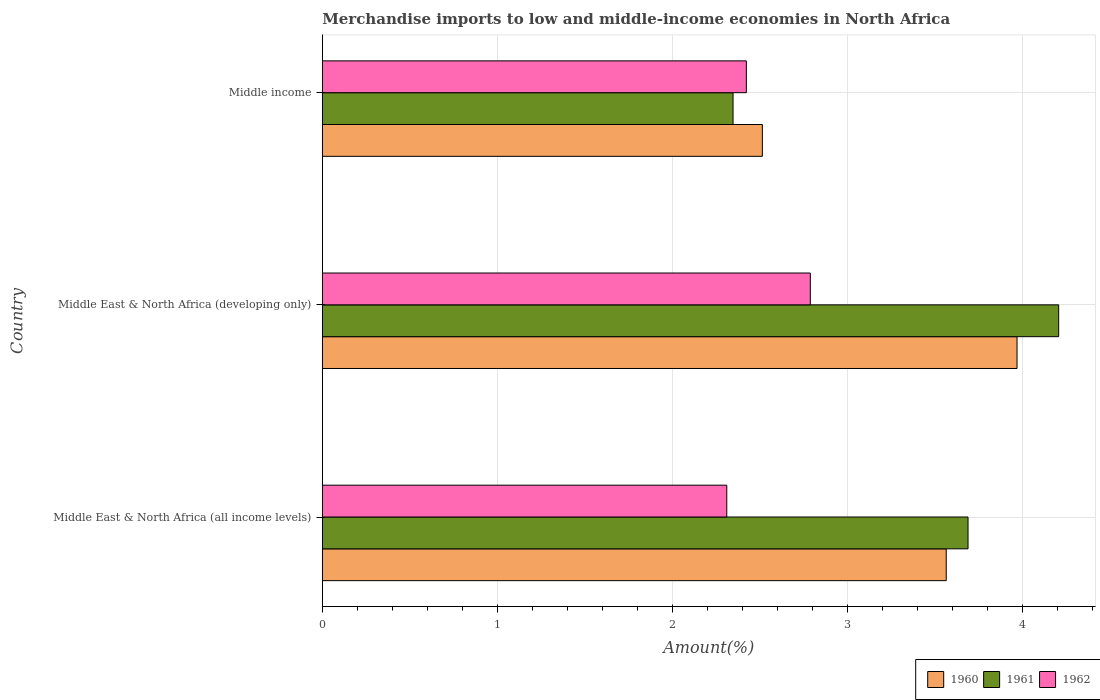How many groups of bars are there?
Provide a short and direct response. 3. Are the number of bars per tick equal to the number of legend labels?
Your answer should be compact. Yes. Are the number of bars on each tick of the Y-axis equal?
Offer a very short reply. Yes. How many bars are there on the 2nd tick from the top?
Provide a short and direct response. 3. How many bars are there on the 1st tick from the bottom?
Offer a very short reply. 3. What is the label of the 2nd group of bars from the top?
Ensure brevity in your answer.  Middle East & North Africa (developing only). In how many cases, is the number of bars for a given country not equal to the number of legend labels?
Offer a terse response. 0. What is the percentage of amount earned from merchandise imports in 1962 in Middle East & North Africa (all income levels)?
Offer a very short reply. 2.31. Across all countries, what is the maximum percentage of amount earned from merchandise imports in 1962?
Offer a terse response. 2.79. Across all countries, what is the minimum percentage of amount earned from merchandise imports in 1962?
Keep it short and to the point. 2.31. In which country was the percentage of amount earned from merchandise imports in 1961 maximum?
Make the answer very short. Middle East & North Africa (developing only). In which country was the percentage of amount earned from merchandise imports in 1960 minimum?
Offer a terse response. Middle income. What is the total percentage of amount earned from merchandise imports in 1960 in the graph?
Offer a very short reply. 10.05. What is the difference between the percentage of amount earned from merchandise imports in 1960 in Middle East & North Africa (developing only) and that in Middle income?
Provide a short and direct response. 1.46. What is the difference between the percentage of amount earned from merchandise imports in 1961 in Middle income and the percentage of amount earned from merchandise imports in 1962 in Middle East & North Africa (all income levels)?
Provide a short and direct response. 0.04. What is the average percentage of amount earned from merchandise imports in 1961 per country?
Give a very brief answer. 3.42. What is the difference between the percentage of amount earned from merchandise imports in 1960 and percentage of amount earned from merchandise imports in 1962 in Middle East & North Africa (all income levels)?
Keep it short and to the point. 1.25. What is the ratio of the percentage of amount earned from merchandise imports in 1962 in Middle East & North Africa (all income levels) to that in Middle East & North Africa (developing only)?
Ensure brevity in your answer.  0.83. Is the percentage of amount earned from merchandise imports in 1960 in Middle East & North Africa (all income levels) less than that in Middle East & North Africa (developing only)?
Make the answer very short. Yes. What is the difference between the highest and the second highest percentage of amount earned from merchandise imports in 1960?
Your response must be concise. 0.4. What is the difference between the highest and the lowest percentage of amount earned from merchandise imports in 1960?
Ensure brevity in your answer.  1.46. In how many countries, is the percentage of amount earned from merchandise imports in 1960 greater than the average percentage of amount earned from merchandise imports in 1960 taken over all countries?
Offer a terse response. 2. Is the sum of the percentage of amount earned from merchandise imports in 1960 in Middle East & North Africa (developing only) and Middle income greater than the maximum percentage of amount earned from merchandise imports in 1961 across all countries?
Ensure brevity in your answer.  Yes. What does the 2nd bar from the top in Middle East & North Africa (developing only) represents?
Offer a very short reply. 1961. Are all the bars in the graph horizontal?
Make the answer very short. Yes. How many countries are there in the graph?
Your answer should be compact. 3. Does the graph contain any zero values?
Offer a very short reply. No. What is the title of the graph?
Your answer should be compact. Merchandise imports to low and middle-income economies in North Africa. Does "2014" appear as one of the legend labels in the graph?
Make the answer very short. No. What is the label or title of the X-axis?
Provide a short and direct response. Amount(%). What is the Amount(%) of 1960 in Middle East & North Africa (all income levels)?
Provide a succinct answer. 3.57. What is the Amount(%) of 1961 in Middle East & North Africa (all income levels)?
Provide a short and direct response. 3.69. What is the Amount(%) in 1962 in Middle East & North Africa (all income levels)?
Your response must be concise. 2.31. What is the Amount(%) in 1960 in Middle East & North Africa (developing only)?
Provide a succinct answer. 3.97. What is the Amount(%) of 1961 in Middle East & North Africa (developing only)?
Offer a very short reply. 4.21. What is the Amount(%) in 1962 in Middle East & North Africa (developing only)?
Your answer should be compact. 2.79. What is the Amount(%) in 1960 in Middle income?
Ensure brevity in your answer.  2.52. What is the Amount(%) of 1961 in Middle income?
Your answer should be compact. 2.35. What is the Amount(%) of 1962 in Middle income?
Offer a very short reply. 2.42. Across all countries, what is the maximum Amount(%) of 1960?
Ensure brevity in your answer.  3.97. Across all countries, what is the maximum Amount(%) of 1961?
Provide a succinct answer. 4.21. Across all countries, what is the maximum Amount(%) of 1962?
Offer a terse response. 2.79. Across all countries, what is the minimum Amount(%) in 1960?
Offer a very short reply. 2.52. Across all countries, what is the minimum Amount(%) of 1961?
Keep it short and to the point. 2.35. Across all countries, what is the minimum Amount(%) in 1962?
Provide a short and direct response. 2.31. What is the total Amount(%) in 1960 in the graph?
Your answer should be compact. 10.05. What is the total Amount(%) of 1961 in the graph?
Offer a terse response. 10.25. What is the total Amount(%) in 1962 in the graph?
Your answer should be compact. 7.53. What is the difference between the Amount(%) of 1960 in Middle East & North Africa (all income levels) and that in Middle East & North Africa (developing only)?
Ensure brevity in your answer.  -0.4. What is the difference between the Amount(%) in 1961 in Middle East & North Africa (all income levels) and that in Middle East & North Africa (developing only)?
Your answer should be very brief. -0.52. What is the difference between the Amount(%) of 1962 in Middle East & North Africa (all income levels) and that in Middle East & North Africa (developing only)?
Your answer should be very brief. -0.48. What is the difference between the Amount(%) of 1960 in Middle East & North Africa (all income levels) and that in Middle income?
Offer a terse response. 1.05. What is the difference between the Amount(%) of 1961 in Middle East & North Africa (all income levels) and that in Middle income?
Keep it short and to the point. 1.34. What is the difference between the Amount(%) in 1962 in Middle East & North Africa (all income levels) and that in Middle income?
Provide a succinct answer. -0.11. What is the difference between the Amount(%) of 1960 in Middle East & North Africa (developing only) and that in Middle income?
Give a very brief answer. 1.46. What is the difference between the Amount(%) of 1961 in Middle East & North Africa (developing only) and that in Middle income?
Your answer should be compact. 1.86. What is the difference between the Amount(%) of 1962 in Middle East & North Africa (developing only) and that in Middle income?
Keep it short and to the point. 0.37. What is the difference between the Amount(%) in 1960 in Middle East & North Africa (all income levels) and the Amount(%) in 1961 in Middle East & North Africa (developing only)?
Offer a terse response. -0.64. What is the difference between the Amount(%) in 1960 in Middle East & North Africa (all income levels) and the Amount(%) in 1962 in Middle East & North Africa (developing only)?
Give a very brief answer. 0.78. What is the difference between the Amount(%) of 1961 in Middle East & North Africa (all income levels) and the Amount(%) of 1962 in Middle East & North Africa (developing only)?
Make the answer very short. 0.9. What is the difference between the Amount(%) of 1960 in Middle East & North Africa (all income levels) and the Amount(%) of 1961 in Middle income?
Ensure brevity in your answer.  1.22. What is the difference between the Amount(%) of 1960 in Middle East & North Africa (all income levels) and the Amount(%) of 1962 in Middle income?
Your answer should be very brief. 1.14. What is the difference between the Amount(%) in 1961 in Middle East & North Africa (all income levels) and the Amount(%) in 1962 in Middle income?
Your answer should be compact. 1.27. What is the difference between the Amount(%) of 1960 in Middle East & North Africa (developing only) and the Amount(%) of 1961 in Middle income?
Your answer should be compact. 1.62. What is the difference between the Amount(%) in 1960 in Middle East & North Africa (developing only) and the Amount(%) in 1962 in Middle income?
Provide a succinct answer. 1.55. What is the difference between the Amount(%) of 1961 in Middle East & North Africa (developing only) and the Amount(%) of 1962 in Middle income?
Make the answer very short. 1.79. What is the average Amount(%) of 1960 per country?
Offer a terse response. 3.35. What is the average Amount(%) in 1961 per country?
Your answer should be compact. 3.42. What is the average Amount(%) of 1962 per country?
Ensure brevity in your answer.  2.51. What is the difference between the Amount(%) of 1960 and Amount(%) of 1961 in Middle East & North Africa (all income levels)?
Keep it short and to the point. -0.12. What is the difference between the Amount(%) of 1960 and Amount(%) of 1962 in Middle East & North Africa (all income levels)?
Make the answer very short. 1.25. What is the difference between the Amount(%) of 1961 and Amount(%) of 1962 in Middle East & North Africa (all income levels)?
Offer a terse response. 1.38. What is the difference between the Amount(%) of 1960 and Amount(%) of 1961 in Middle East & North Africa (developing only)?
Offer a terse response. -0.24. What is the difference between the Amount(%) of 1960 and Amount(%) of 1962 in Middle East & North Africa (developing only)?
Keep it short and to the point. 1.18. What is the difference between the Amount(%) in 1961 and Amount(%) in 1962 in Middle East & North Africa (developing only)?
Offer a terse response. 1.42. What is the difference between the Amount(%) of 1960 and Amount(%) of 1961 in Middle income?
Your answer should be compact. 0.17. What is the difference between the Amount(%) in 1960 and Amount(%) in 1962 in Middle income?
Make the answer very short. 0.09. What is the difference between the Amount(%) in 1961 and Amount(%) in 1962 in Middle income?
Provide a succinct answer. -0.08. What is the ratio of the Amount(%) of 1960 in Middle East & North Africa (all income levels) to that in Middle East & North Africa (developing only)?
Your answer should be compact. 0.9. What is the ratio of the Amount(%) in 1961 in Middle East & North Africa (all income levels) to that in Middle East & North Africa (developing only)?
Provide a short and direct response. 0.88. What is the ratio of the Amount(%) of 1962 in Middle East & North Africa (all income levels) to that in Middle East & North Africa (developing only)?
Give a very brief answer. 0.83. What is the ratio of the Amount(%) in 1960 in Middle East & North Africa (all income levels) to that in Middle income?
Make the answer very short. 1.42. What is the ratio of the Amount(%) in 1961 in Middle East & North Africa (all income levels) to that in Middle income?
Your answer should be very brief. 1.57. What is the ratio of the Amount(%) of 1962 in Middle East & North Africa (all income levels) to that in Middle income?
Offer a very short reply. 0.95. What is the ratio of the Amount(%) of 1960 in Middle East & North Africa (developing only) to that in Middle income?
Make the answer very short. 1.58. What is the ratio of the Amount(%) of 1961 in Middle East & North Africa (developing only) to that in Middle income?
Give a very brief answer. 1.79. What is the ratio of the Amount(%) in 1962 in Middle East & North Africa (developing only) to that in Middle income?
Make the answer very short. 1.15. What is the difference between the highest and the second highest Amount(%) in 1960?
Provide a short and direct response. 0.4. What is the difference between the highest and the second highest Amount(%) in 1961?
Your response must be concise. 0.52. What is the difference between the highest and the second highest Amount(%) of 1962?
Make the answer very short. 0.37. What is the difference between the highest and the lowest Amount(%) in 1960?
Keep it short and to the point. 1.46. What is the difference between the highest and the lowest Amount(%) in 1961?
Ensure brevity in your answer.  1.86. What is the difference between the highest and the lowest Amount(%) of 1962?
Your response must be concise. 0.48. 